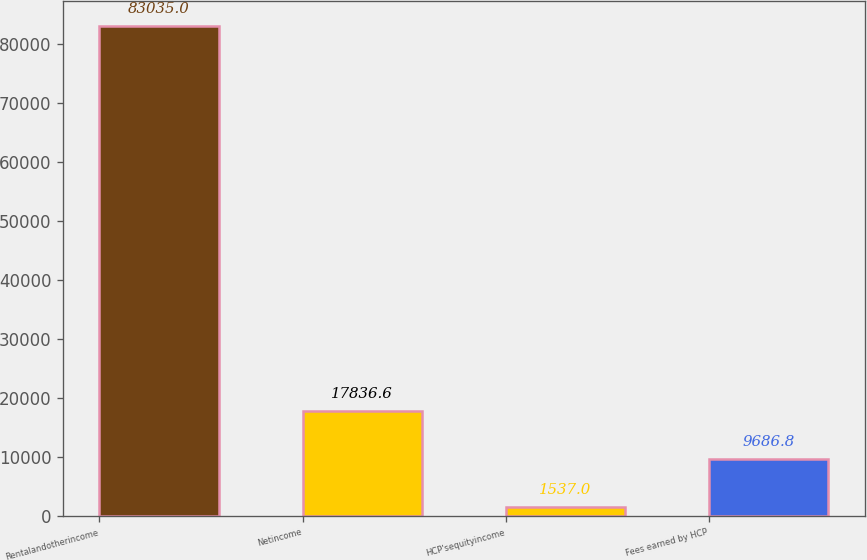Convert chart. <chart><loc_0><loc_0><loc_500><loc_500><bar_chart><fcel>Rentalandotherincome<fcel>Netincome<fcel>HCP'sequityincome<fcel>Fees earned by HCP<nl><fcel>83035<fcel>17836.6<fcel>1537<fcel>9686.8<nl></chart> 